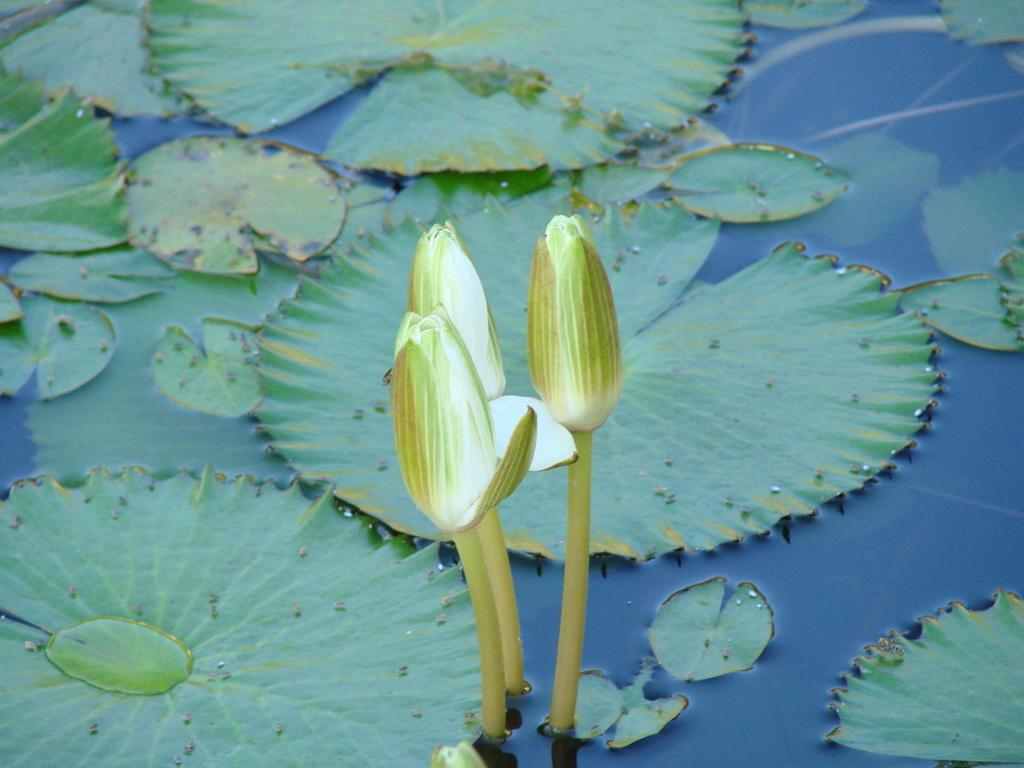What type of plants can be seen in the image? The image contains flowers. Can you describe the location of the leaves in the image? There are leaves on the water at the bottom of the image. What type of society is depicted in the image? There is no society depicted in the image; it features flowers and leaves on water. Can you describe the beetle crawling on the petals of the flowers in the image? There is no beetle present in the image; it only contains flowers and leaves on water. 